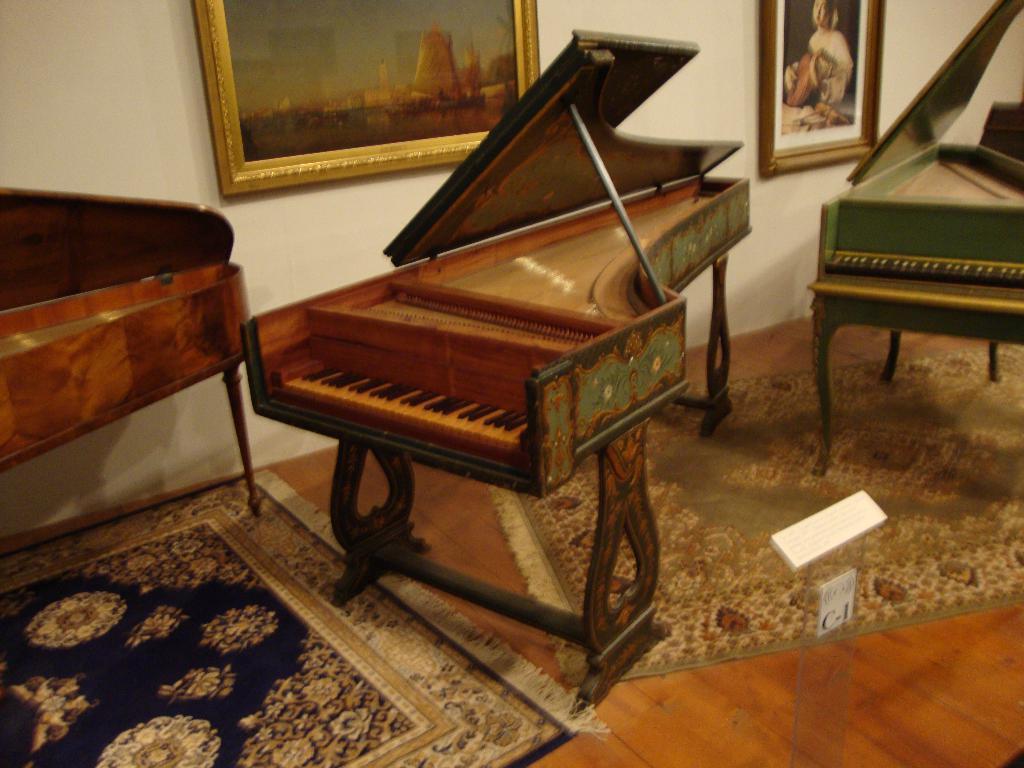In one or two sentences, can you explain what this image depicts? In this picture we can see a few carpets on the floor. There is glass object and a white object visible on the floor. We can see a few pianos from left to right. There are a few frames visible on the wall. 